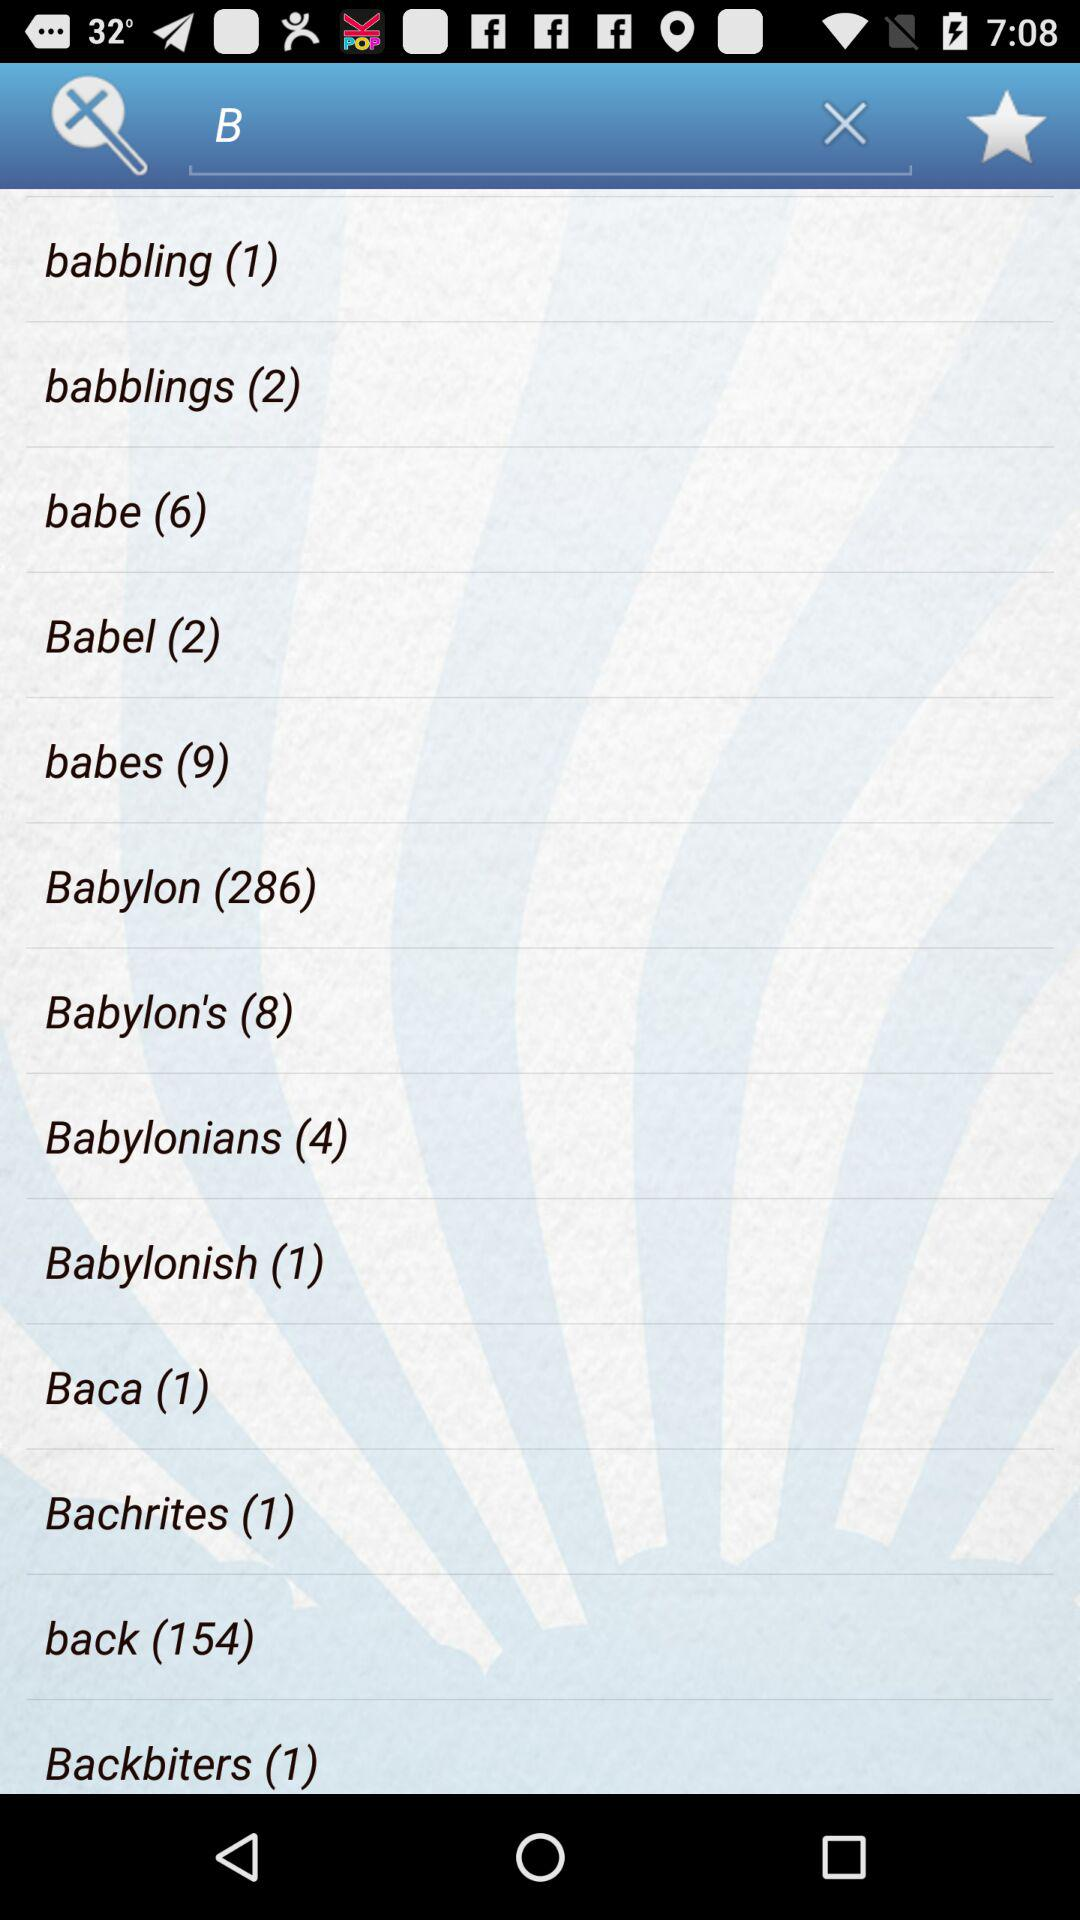What's the total number of items in "babbling"? The total number of items in "babbling" is 1. 